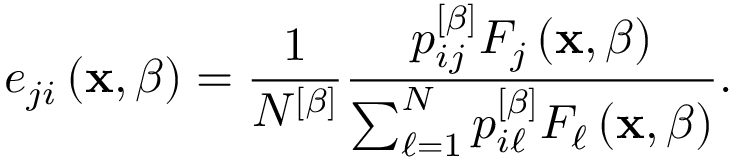<formula> <loc_0><loc_0><loc_500><loc_500>e _ { j i } \left ( x , \beta \right ) = \frac { 1 } { N ^ { \left [ \beta \right ] } } \frac { p _ { i j } ^ { \left [ \beta \right ] } F _ { j } \left ( x , \beta \right ) } { \sum _ { \ell = 1 } ^ { N } p _ { i \ell } ^ { \left [ \beta \right ] } F _ { \ell } \left ( x , \beta \right ) } .</formula> 